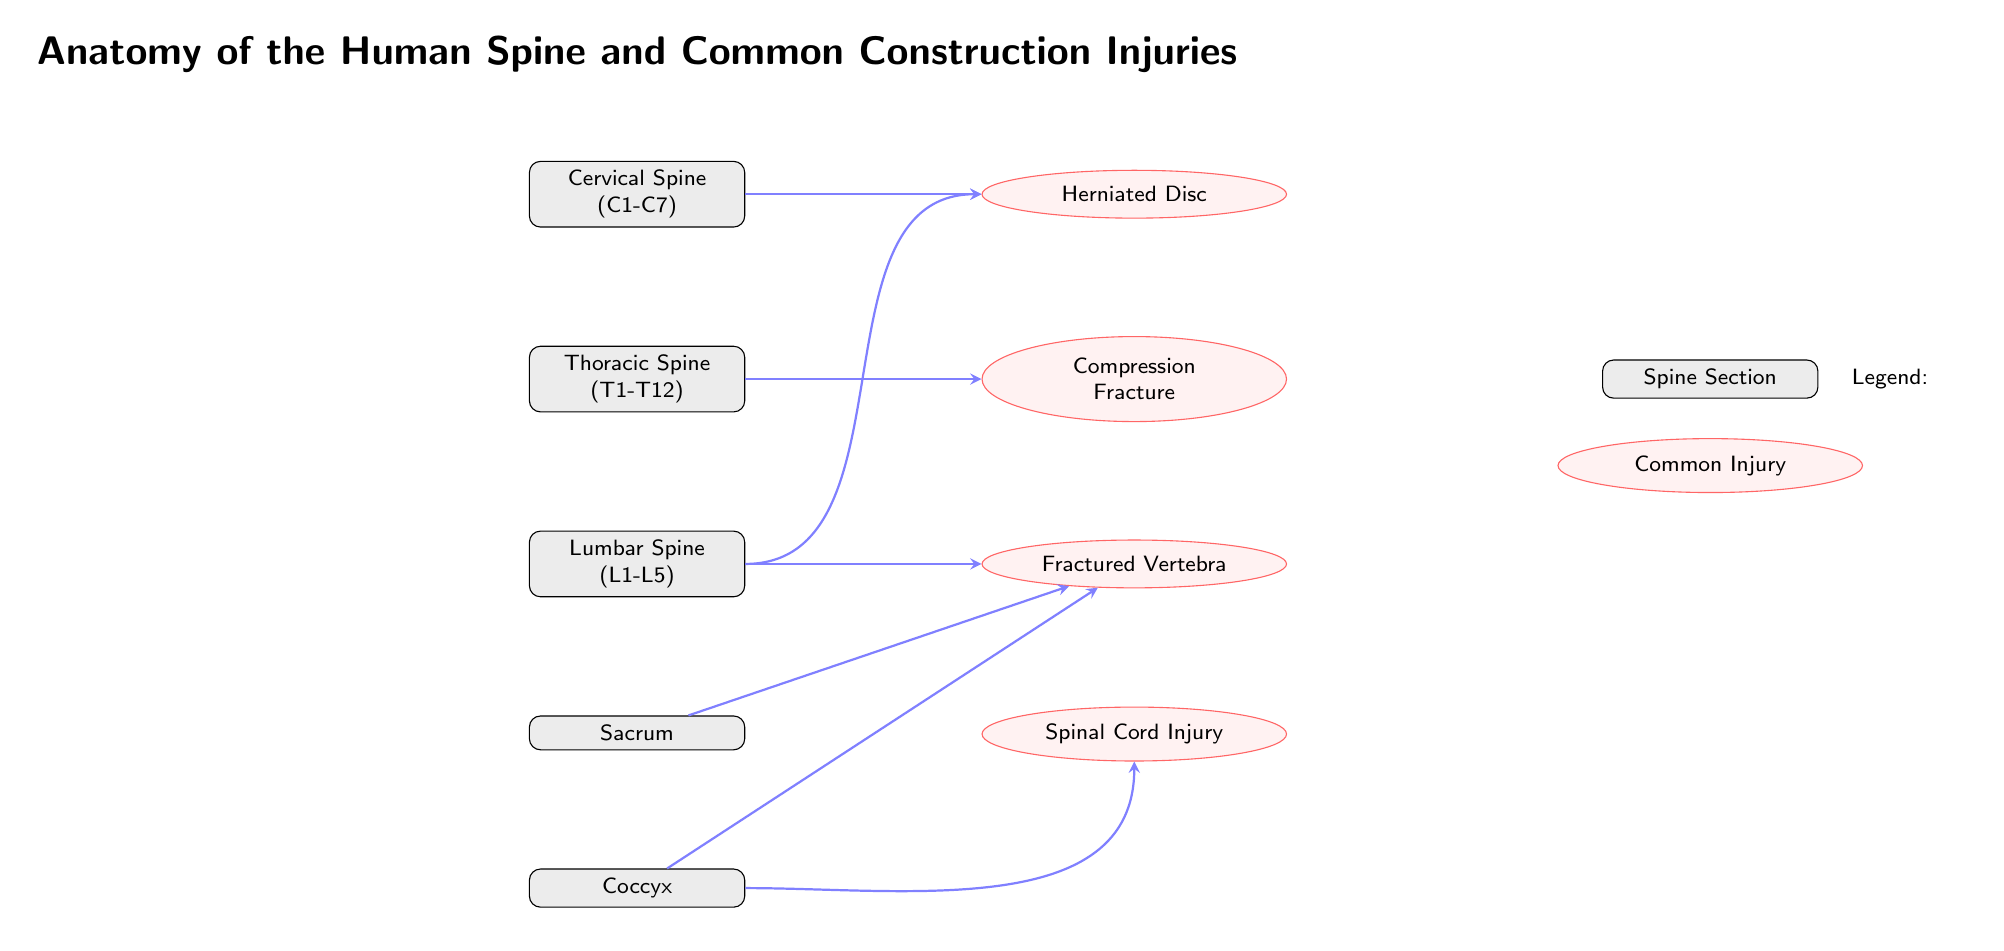What types of injuries are associated with the lumbar spine? The diagram shows a connection from the lumbar spine node to the "Fractured Vertebra" and "Herniated Disc" injury nodes. This indicates that these injuries are associated with the lumbar section of the spine.
Answer: Fractured Vertebra, Herniated Disc How many sections are labeled in the spine? The diagram comprises five labeled sections of the spine: Cervical, Thoracic, Lumbar, Sacrum, and Coccyx. Therefore, a total of five sections are listed.
Answer: 5 Which injury is linked to the cervical spine? The connection from the cervical spine node points directly to the injury node labeled "Herniated Disc", indicating this is the specific injury associated with the cervical section.
Answer: Herniated Disc What type of injury is indicated for the thoracic spine? The thoracic spine node in the diagram has a direct arrow pointing to the "Compression Fracture" injury node, showing that this particular injury is associated with the thoracic region.
Answer: Compression Fracture Which spinal section has two types of injuries connected to it? The lumbar spine is illustrated with connections leading to both "Fractured Vertebra" and "Herniated Disc", indicating that it is associated with two types of injuries.
Answer: Lumbar Spine 